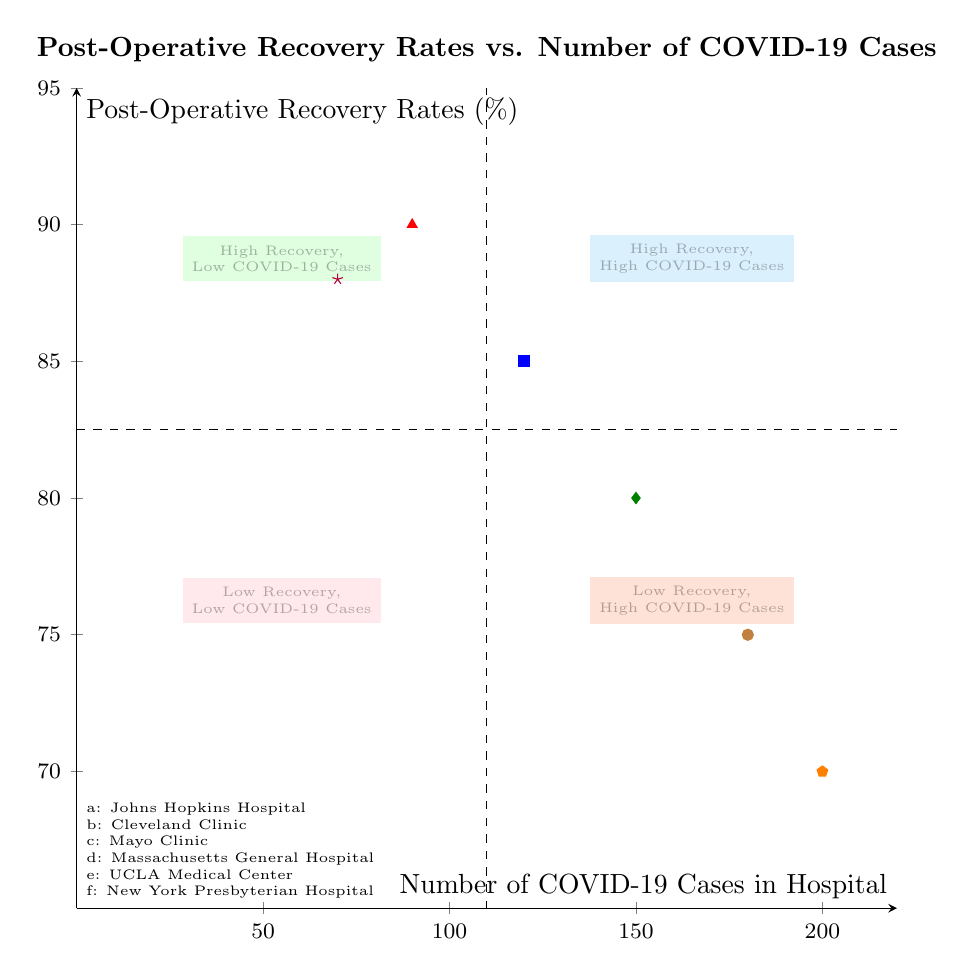What are the post-operative recovery rates for Johns Hopkins Hospital? The diagram shows the data point for Johns Hopkins Hospital at the coordinates (120, 85). This means its post-operative recovery rate is 85%.
Answer: 85% Which hospital has the lowest number of COVID-19 cases? On examining the diagram, UCLA Medical Center is located at (70, 88), which has the lowest number of COVID-19 cases compared to the others.
Answer: UCLA Medical Center What is the post-operative recovery rate in the quadrant with high COVID-19 cases? In the "High Recovery, High COVID-19 Cases" quadrant (top right), hospitals like Johns Hopkins Hospital (120, 85) and Mayo Clinic (150, 80) are present, but the highest recovery rate here is 85% for Johns Hopkins Hospital.
Answer: 85% How many hospitals fall into the "Low Recovery, High COVID-19 Cases" quadrant? By analyzing the diagram, there is only one data point that falls into the "Low Recovery, High COVID-19 Cases" quadrant with Massachusetts General Hospital at (200, 70).
Answer: 1 What is the recovery rate of the Cleveland Clinic? The Cleveland Clinic is shown at the coordinates (90, 90), indicating its post-operative recovery rate is 90%.
Answer: 90% What is the relationship between COVID-19 cases and recovery rates in Massachusetts General Hospital? Massachusetts General Hospital is positioned in the "Low Recovery, High COVID-19 Cases" quadrant, reflecting a higher number of COVID-19 cases (200) and a low recovery rate (70%). This indicates that higher COVID-19 cases are associated with lower recovery rates for this hospital.
Answer: High COVID-19 cases, Low Recovery Rate Which quadrant has hospitals with both high recovery rates and high COVID-19 cases? The "High Recovery, High COVID-19 Cases" quadrant features hospitals that achieve high recovery rates despite a higher number of COVID-19 cases. In this case, hospitals like Johns Hopkins Hospital and Mayo Clinic fit this description.
Answer: High Recovery, High COVID-19 Cases What is the maximum recovery rate observed in the "Low Recovery, Low COVID-19 Cases" quadrant? Looking at the "Low Recovery, Low COVID-19 Cases" quadrant, it contains a recovery rate of 80% for the Mayo Clinic. This reflects that, although this quadrant generally indicates low recovery, there can still be hospitals like Mayo Clinic showing comparatively better rates.
Answer: 80% 